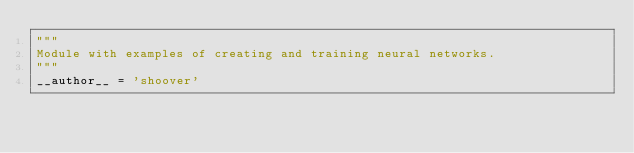<code> <loc_0><loc_0><loc_500><loc_500><_Python_>"""
Module with examples of creating and training neural networks.
"""
__author__ = 'shoover'
</code> 